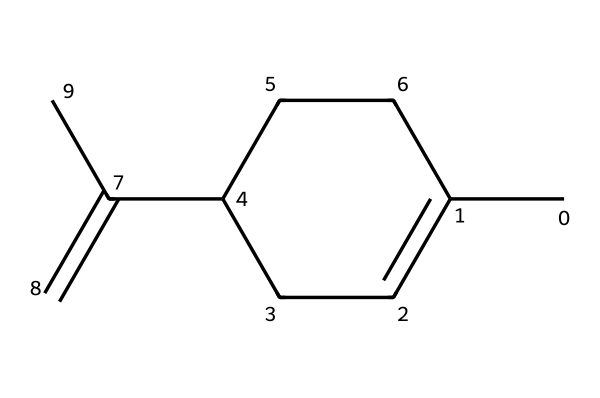How many carbon atoms are in limonene? The SMILES representation indicates a total of 10 carbon atoms, which can be counted from the structure.
Answer: ten What is the molecular formula of limonene? By analyzing the structure represented in the SMILES notation, we derive the molecular formula, which is C10H16.
Answer: C10H16 How many double bonds are present in limonene? The structure contains one double bond, which can be identified between two carbon atoms in the molecule.
Answer: one What type of compound is limonene classified as? Limonene is classified as a terpene, which is evident from its structure and characteristic carbon framework typical of this class of compounds.
Answer: terpene Which part of the chemical structure indicates it has a citrus scent? The presence of the specific arrangement of carbon atoms and the double bonds in limonene is characteristic of the aromatic properties that provide its citrus scent.
Answer: carbon arrangement What is the significance of limonene in religious ceremonies? Limonene is significant in religious ceremonies for its uplifting aroma, which is often associated with purification and renewal.
Answer: uplifting aroma 